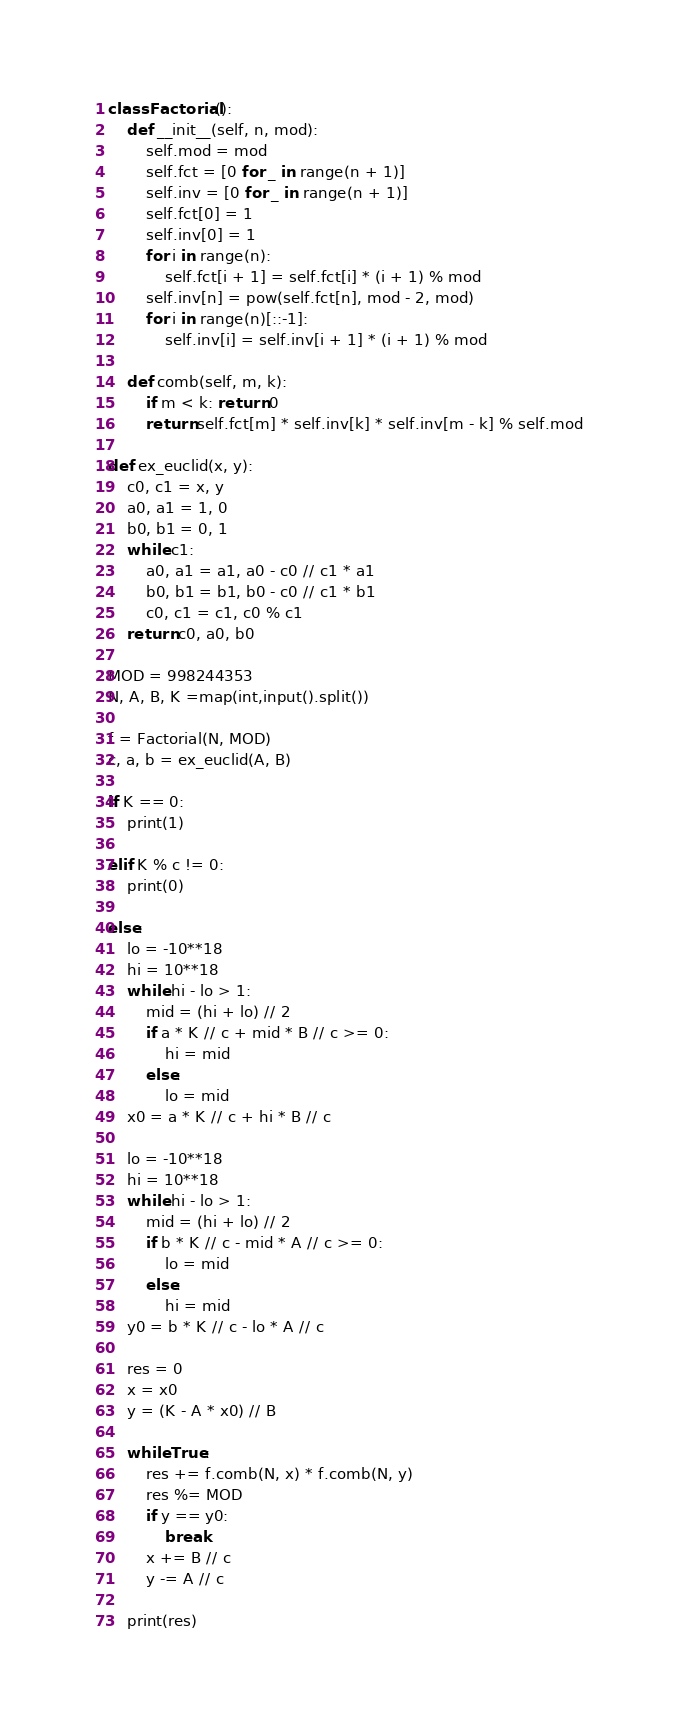Convert code to text. <code><loc_0><loc_0><loc_500><loc_500><_Python_>class Factorial():
    def __init__(self, n, mod):
        self.mod = mod
        self.fct = [0 for _ in range(n + 1)]
        self.inv = [0 for _ in range(n + 1)]
        self.fct[0] = 1
        self.inv[0] = 1
        for i in range(n):
            self.fct[i + 1] = self.fct[i] * (i + 1) % mod
        self.inv[n] = pow(self.fct[n], mod - 2, mod)
        for i in range(n)[::-1]:
            self.inv[i] = self.inv[i + 1] * (i + 1) % mod

    def comb(self, m, k):
        if m < k: return 0
        return self.fct[m] * self.inv[k] * self.inv[m - k] % self.mod

def ex_euclid(x, y):
    c0, c1 = x, y
    a0, a1 = 1, 0
    b0, b1 = 0, 1
    while c1:
        a0, a1 = a1, a0 - c0 // c1 * a1
        b0, b1 = b1, b0 - c0 // c1 * b1
        c0, c1 = c1, c0 % c1
    return c0, a0, b0

MOD = 998244353
N, A, B, K =map(int,input().split())

f = Factorial(N, MOD)
c, a, b = ex_euclid(A, B)

if K == 0:
    print(1)

elif K % c != 0:
    print(0)

else:
    lo = -10**18
    hi = 10**18
    while hi - lo > 1:
        mid = (hi + lo) // 2
        if a * K // c + mid * B // c >= 0:
            hi = mid
        else:
            lo = mid
    x0 = a * K // c + hi * B // c

    lo = -10**18
    hi = 10**18
    while hi - lo > 1:
        mid = (hi + lo) // 2
        if b * K // c - mid * A // c >= 0:
            lo = mid
        else:
            hi = mid
    y0 = b * K // c - lo * A // c

    res = 0
    x = x0
    y = (K - A * x0) // B

    while True:
        res += f.comb(N, x) * f.comb(N, y)
        res %= MOD
        if y == y0:
            break
        x += B // c
        y -= A // c

    print(res)</code> 